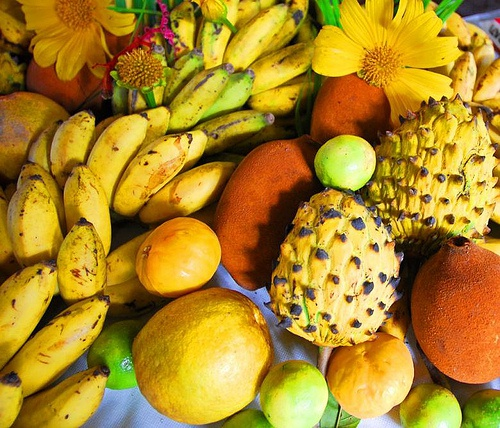Describe the objects in this image and their specific colors. I can see orange in maroon, gold, olive, and orange tones, banana in maroon, gold, and olive tones, orange in maroon, red, and brown tones, banana in maroon, orange, olive, and gold tones, and banana in maroon, gold, and olive tones in this image. 